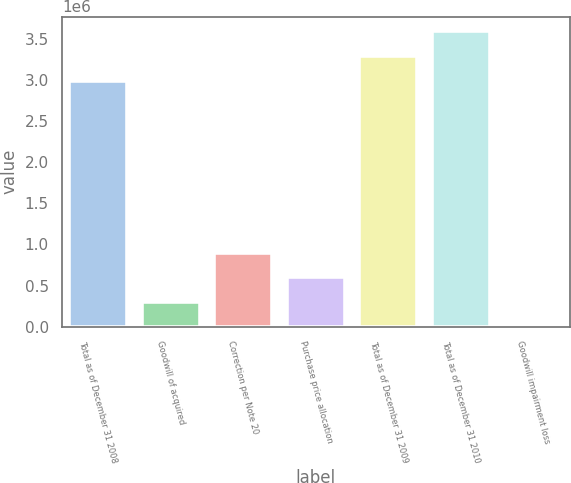Convert chart. <chart><loc_0><loc_0><loc_500><loc_500><bar_chart><fcel>Total as of December 31 2008<fcel>Goodwill of acquired<fcel>Correction per Note 20<fcel>Purchase price allocation<fcel>Total as of December 31 2009<fcel>Total as of December 31 2010<fcel>Goodwill impairment loss<nl><fcel>2.99384e+06<fcel>300541<fcel>901617<fcel>601079<fcel>3.29437e+06<fcel>3.59491e+06<fcel>2.78<nl></chart> 